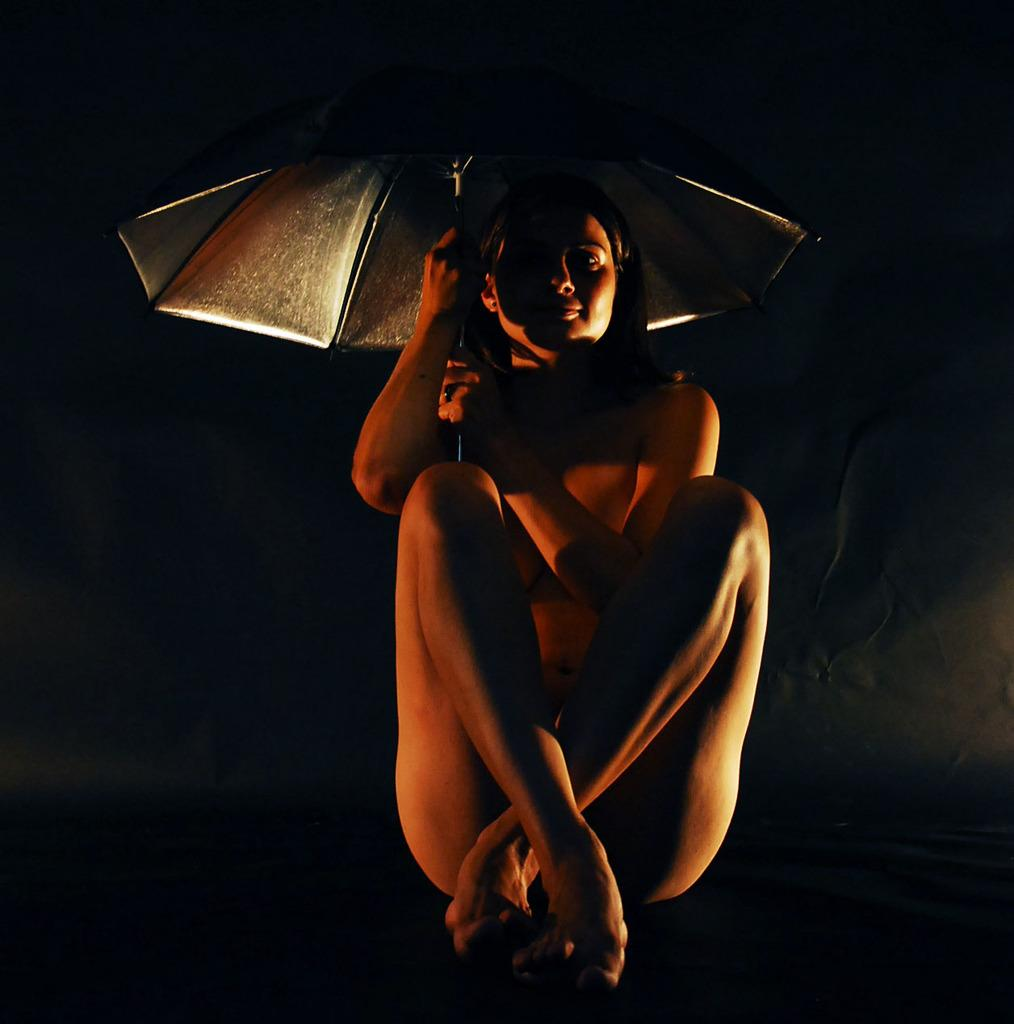Who is present in the image? There is a woman in the image. What is the woman doing in the image? The woman is sitting. What object is the woman holding in the image? The woman is holding an umbrella. How many tickets can be seen in the woman's hand in the image? There are no tickets visible in the woman's hand in the image. What type of bomb is the woman holding in the image? There is no bomb present in the image; the woman is holding an umbrella. 